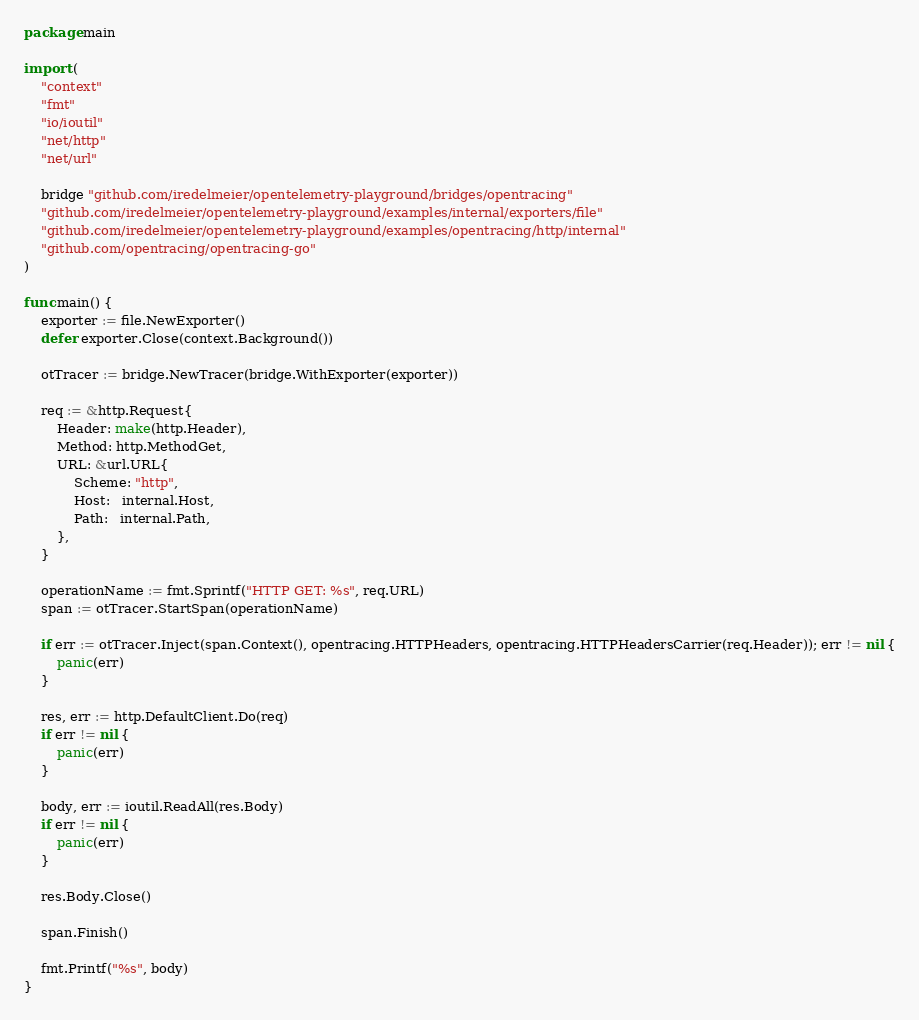Convert code to text. <code><loc_0><loc_0><loc_500><loc_500><_Go_>package main

import (
	"context"
	"fmt"
	"io/ioutil"
	"net/http"
	"net/url"

	bridge "github.com/iredelmeier/opentelemetry-playground/bridges/opentracing"
	"github.com/iredelmeier/opentelemetry-playground/examples/internal/exporters/file"
	"github.com/iredelmeier/opentelemetry-playground/examples/opentracing/http/internal"
	"github.com/opentracing/opentracing-go"
)

func main() {
	exporter := file.NewExporter()
	defer exporter.Close(context.Background())

	otTracer := bridge.NewTracer(bridge.WithExporter(exporter))

	req := &http.Request{
		Header: make(http.Header),
		Method: http.MethodGet,
		URL: &url.URL{
			Scheme: "http",
			Host:   internal.Host,
			Path:   internal.Path,
		},
	}

	operationName := fmt.Sprintf("HTTP GET: %s", req.URL)
	span := otTracer.StartSpan(operationName)

	if err := otTracer.Inject(span.Context(), opentracing.HTTPHeaders, opentracing.HTTPHeadersCarrier(req.Header)); err != nil {
		panic(err)
	}

	res, err := http.DefaultClient.Do(req)
	if err != nil {
		panic(err)
	}

	body, err := ioutil.ReadAll(res.Body)
	if err != nil {
		panic(err)
	}

	res.Body.Close()

	span.Finish()

	fmt.Printf("%s", body)
}
</code> 